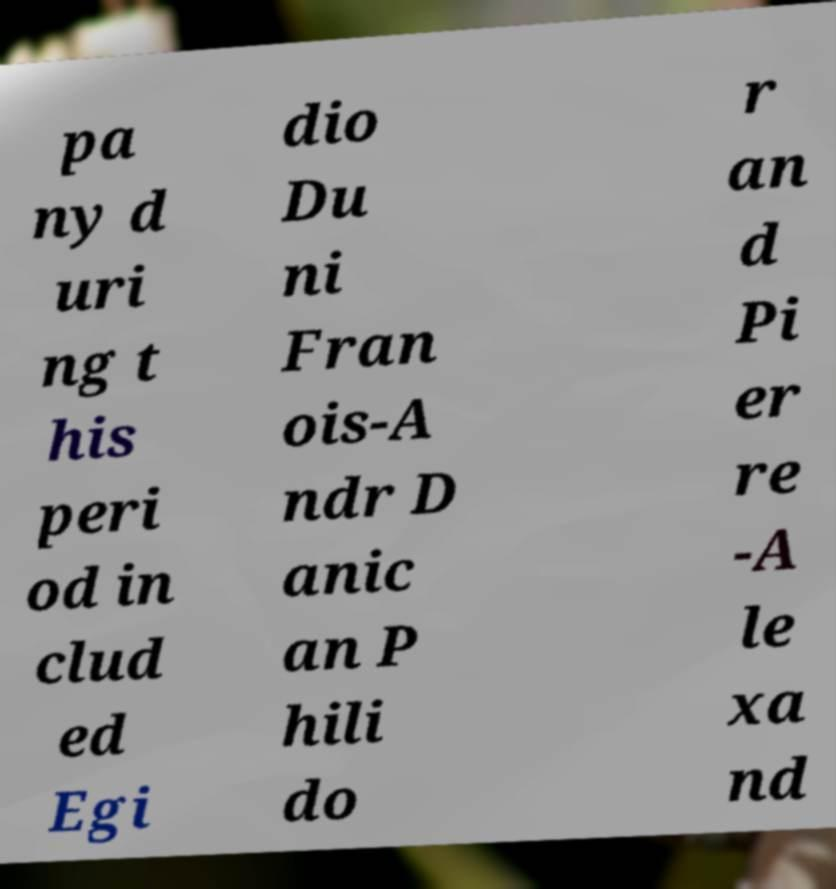Can you accurately transcribe the text from the provided image for me? pa ny d uri ng t his peri od in clud ed Egi dio Du ni Fran ois-A ndr D anic an P hili do r an d Pi er re -A le xa nd 